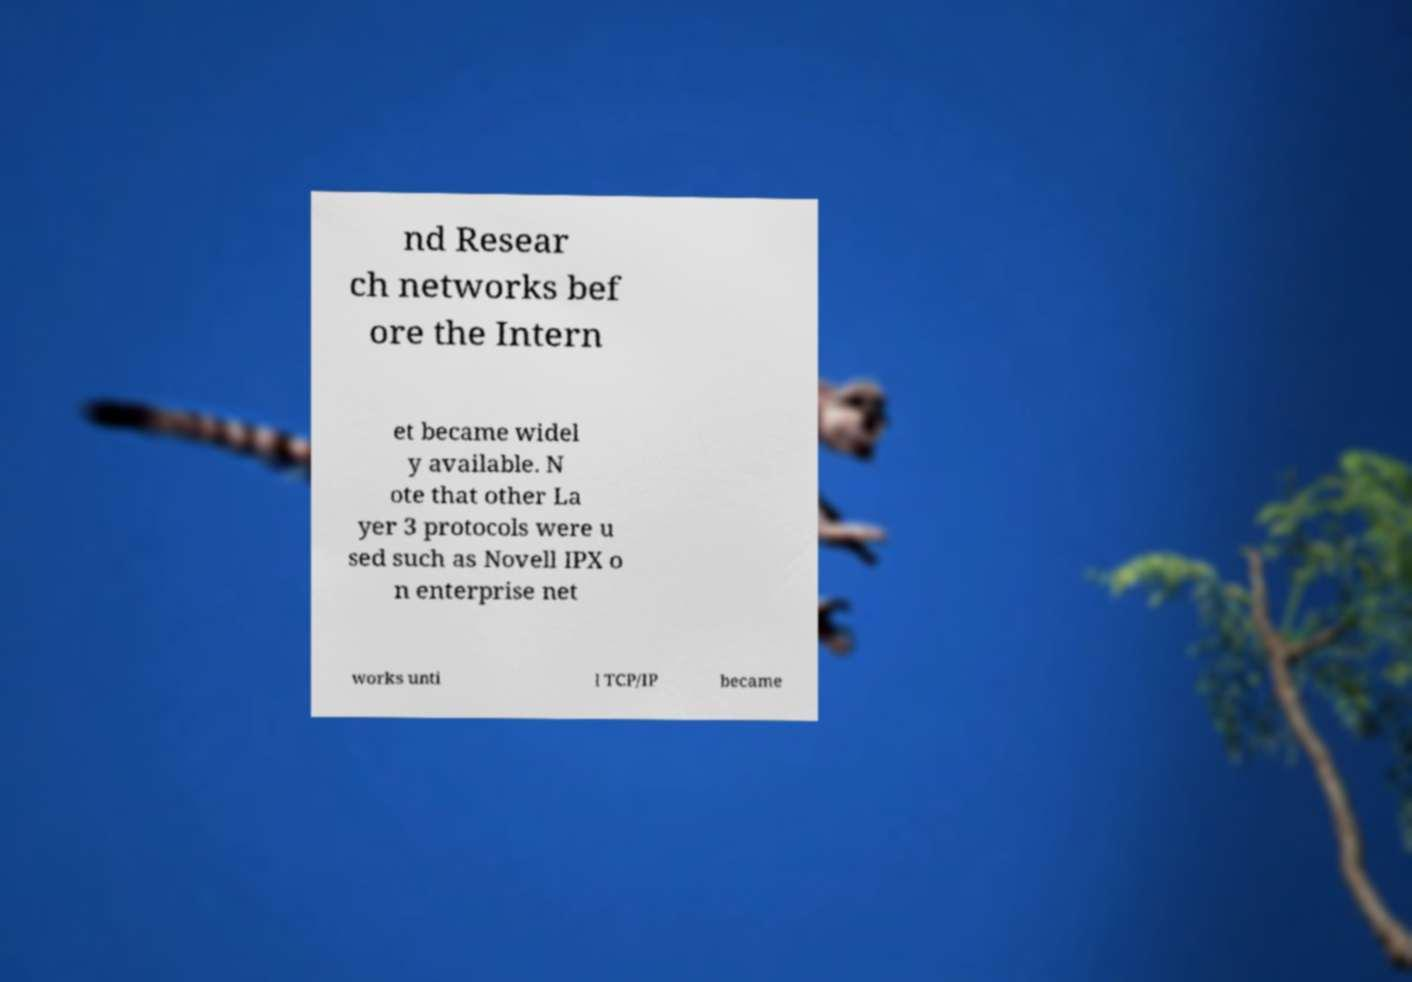Can you accurately transcribe the text from the provided image for me? nd Resear ch networks bef ore the Intern et became widel y available. N ote that other La yer 3 protocols were u sed such as Novell IPX o n enterprise net works unti l TCP/IP became 